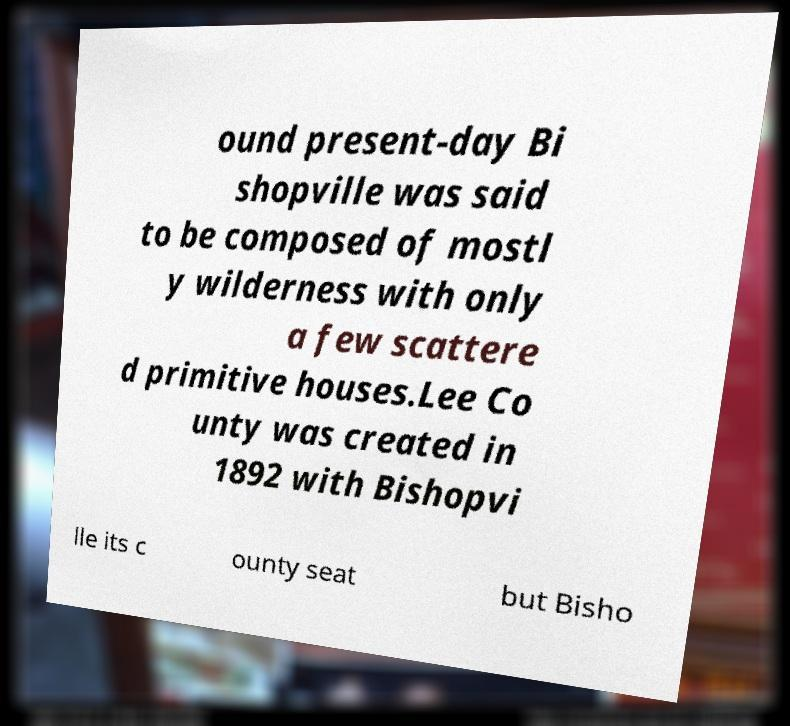Can you accurately transcribe the text from the provided image for me? ound present-day Bi shopville was said to be composed of mostl y wilderness with only a few scattere d primitive houses.Lee Co unty was created in 1892 with Bishopvi lle its c ounty seat but Bisho 